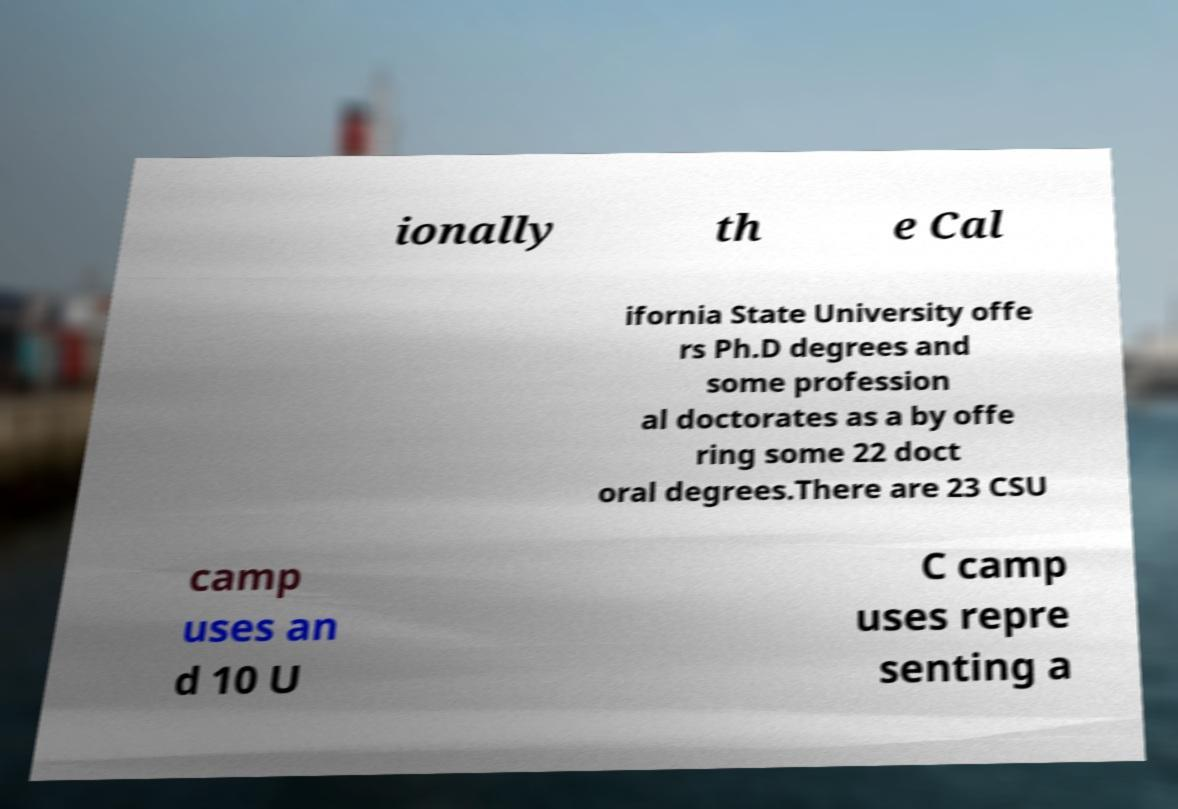Can you accurately transcribe the text from the provided image for me? ionally th e Cal ifornia State University offe rs Ph.D degrees and some profession al doctorates as a by offe ring some 22 doct oral degrees.There are 23 CSU camp uses an d 10 U C camp uses repre senting a 